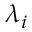Convert formula to latex. <formula><loc_0><loc_0><loc_500><loc_500>\lambda _ { i }</formula> 